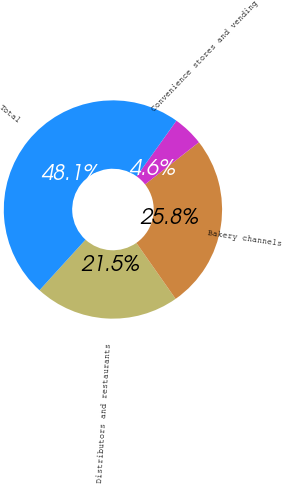Convert chart to OTSL. <chart><loc_0><loc_0><loc_500><loc_500><pie_chart><fcel>Distributors and restaurants<fcel>Bakery channels<fcel>Convenience stores and vending<fcel>Total<nl><fcel>21.48%<fcel>25.83%<fcel>4.56%<fcel>48.13%<nl></chart> 